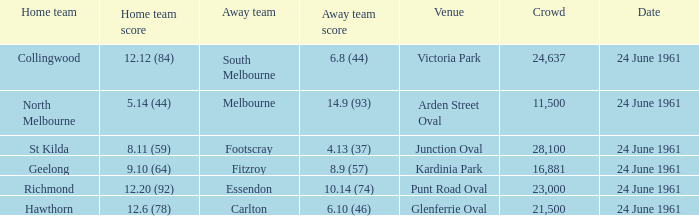Which home side scored 1 Hawthorn. 